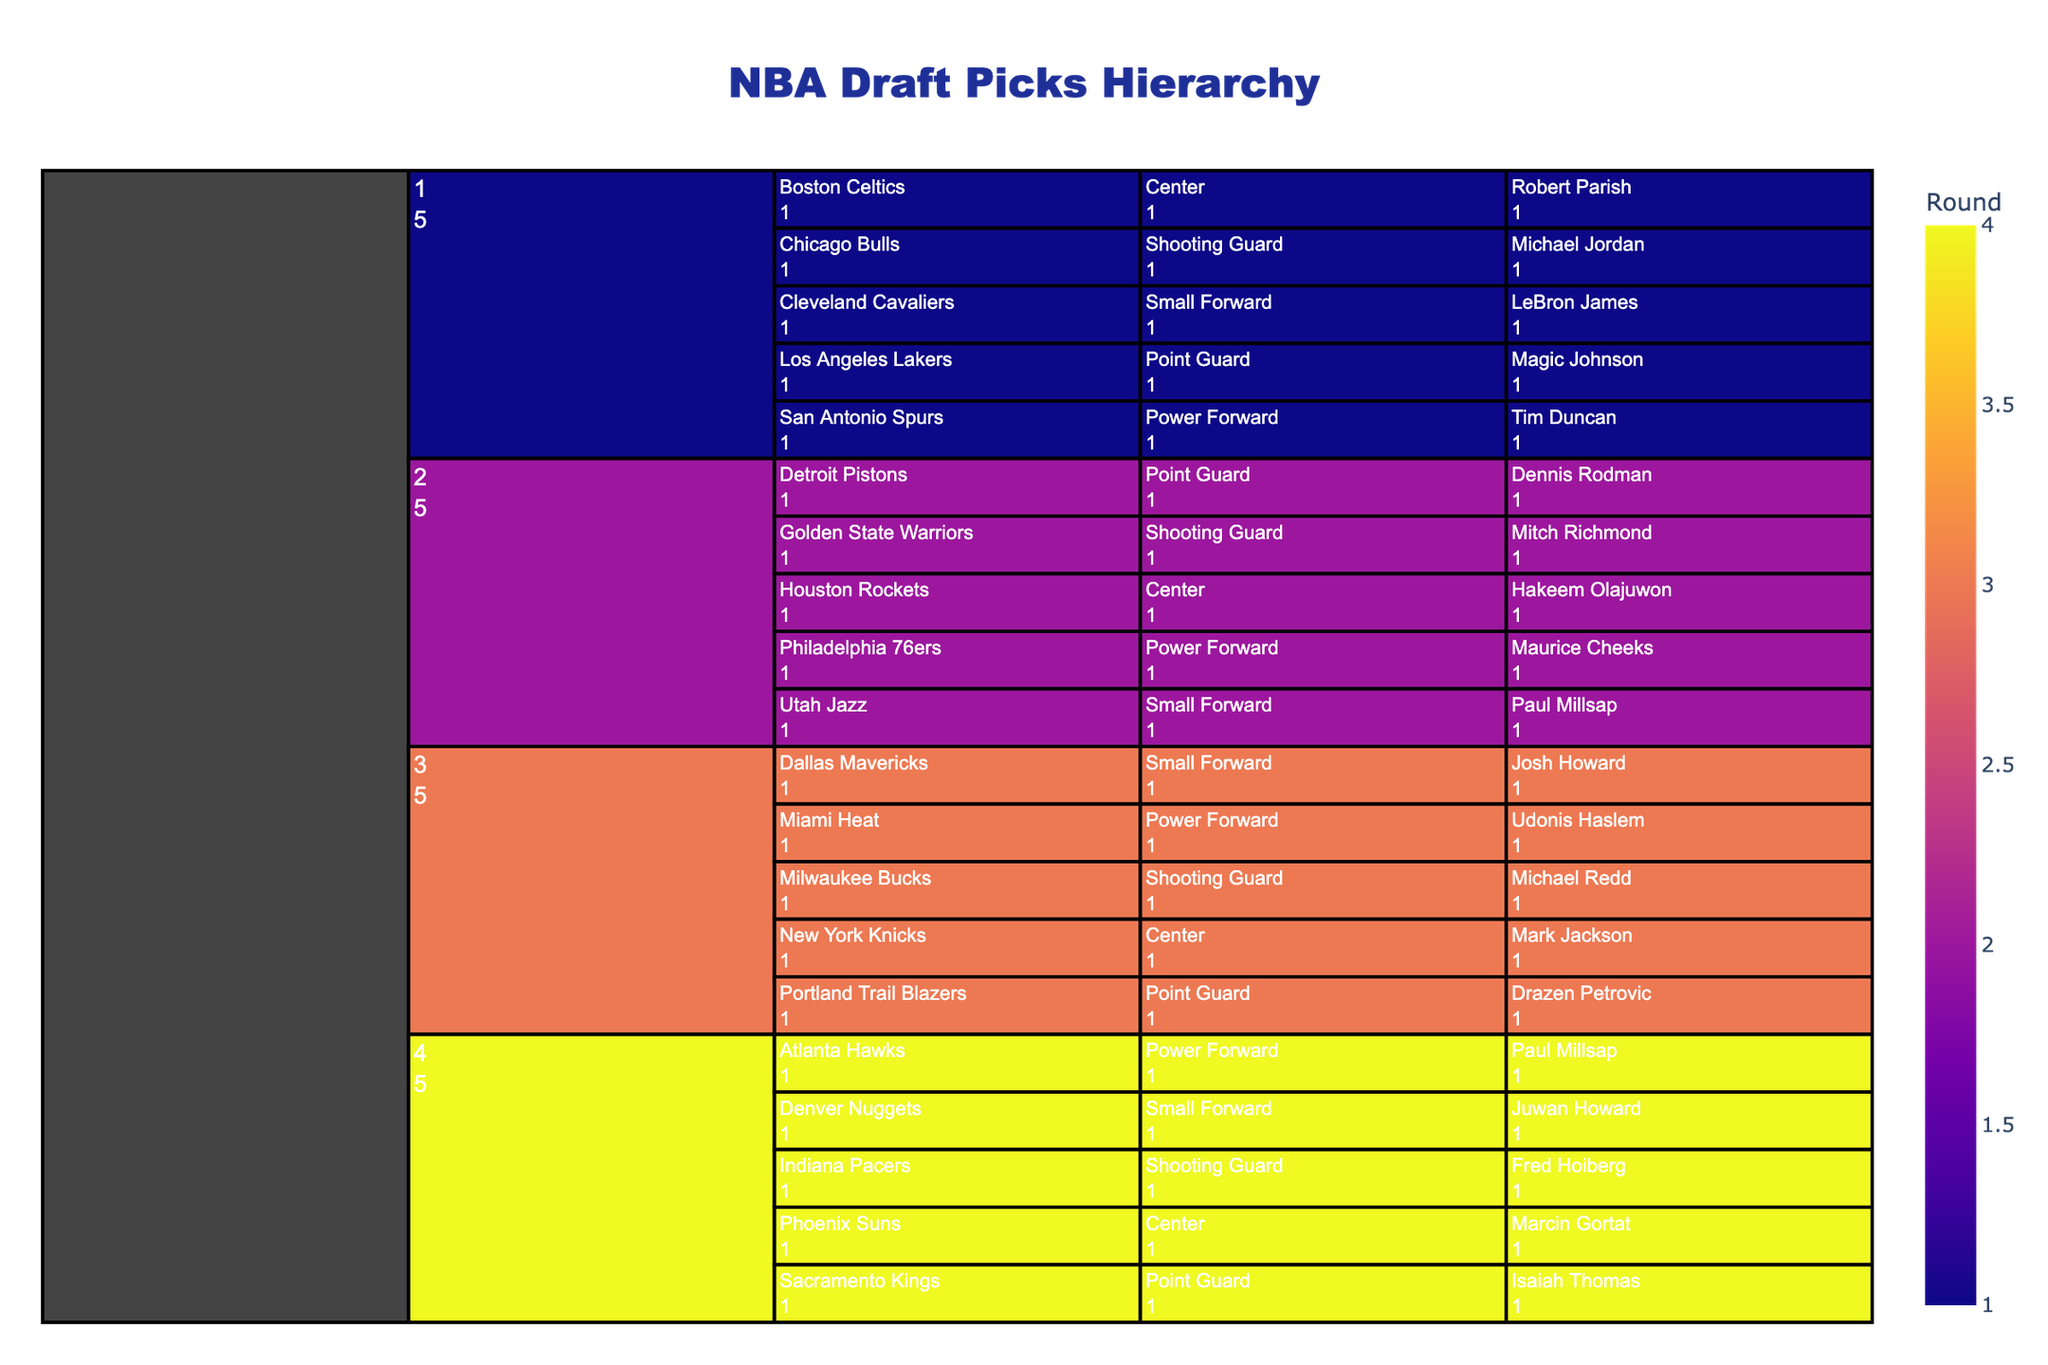How many players were picked in the first round? Count the number of players listed under the first round. There are 5 players in the first round: Robert Parish, Magic Johnson, Michael Jordan, Tim Duncan, and LeBron James.
Answer: 5 Which team picked a player in the third round? Identify the teams listed under the third round. The teams are New York Knicks, Portland Trail Blazers, Milwaukee Bucks, Miami Heat, and Dallas Mavericks.
Answer: New York Knicks, Portland Trail Blazers, Milwaukee Bucks, Miami Heat, Dallas Mavericks How many teams picked a Center during the drafts? Locate the position 'Center' and count the unique teams under this position across all rounds. The teams are Boston Celtics, Houston Rockets, New York Knicks, and Phoenix Suns, which totals to 4 unique teams.
Answer: 4 Which player picked in the fourth round played for the Denver Nuggets? Look under the fourth round and find the Denver Nuggets. The player listed there is Juwan Howard.
Answer: Juwan Howard Compare the number of Shooting Guards picked in the second round to those picked in the third round. Which round had more? Count the Shooting Guards in the second round and the third round. In the second round, there's Mitch Richmond. In the third round, there's Michael Redd. Each round has one Shooting Guard.
Answer: Same Which round had the most players picked? Compare the counts of players in each round. Each round has 5 players, so no round has the most.
Answer: Tie Who was the Small Forward picked by the Cleveland Cavaliers? Look under the first round for the Cleveland Cavaliers and identify the player listed as a Small Forward, which is LeBron James.
Answer: LeBron James Was Maurice Cheeks selected before or after Michael Jordan? Determine the rounds in which Maurice Cheeks and Michael Jordan were picked. Michael Jordan was picked in the first round while Maurice Cheeks was picked in the second round. Therefore, Michael Jordan was picked before Maurice Cheeks.
Answer: Before Which teams picked multiple players from the same position? Identify teams that appear more than once under the same position. San Antonio Spurs appear twice but with different positions, so no team picked multiple players from the same position.
Answer: None 